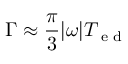<formula> <loc_0><loc_0><loc_500><loc_500>\Gamma \approx \frac { \pi } { 3 } | \omega | T _ { e d }</formula> 